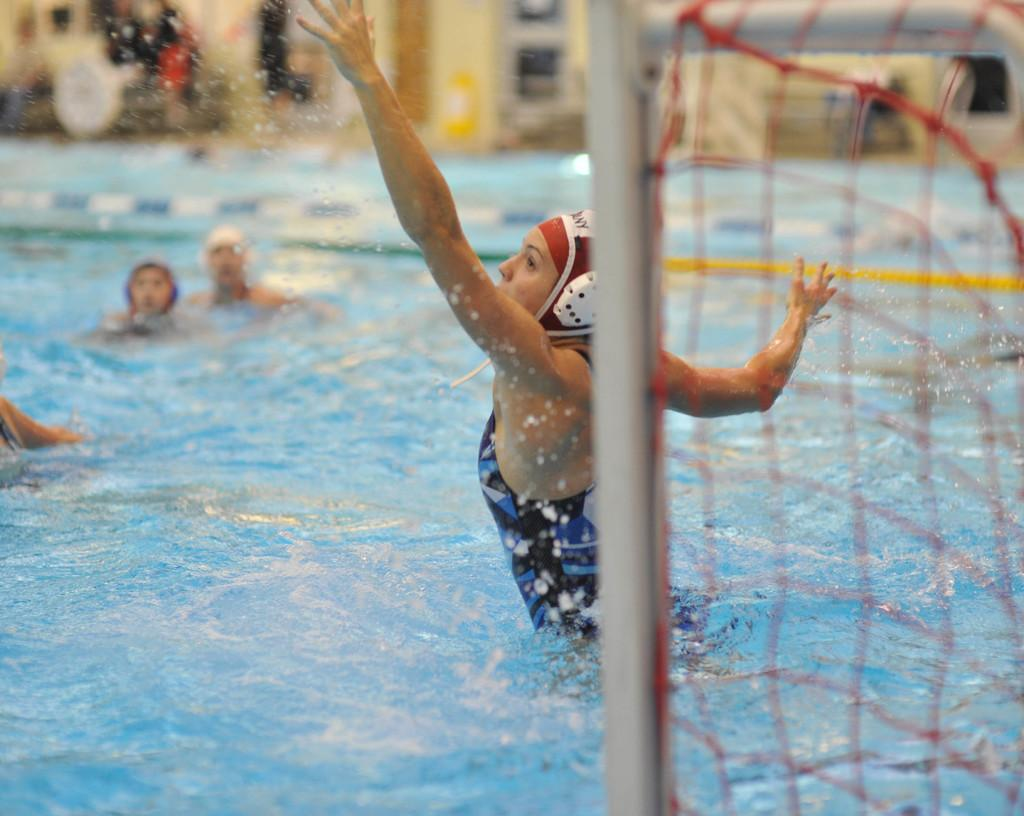What activity are the people in the image engaged in? The people in the image are in a swimming pool. What object can be seen on the right side of the image? There is a net on the right side of the image. Can you describe the background of the image? The background of the image is blurred. What type of mist is covering the people in the swimming pool? There is no mist present in the image; the people are swimming in a clear pool. 